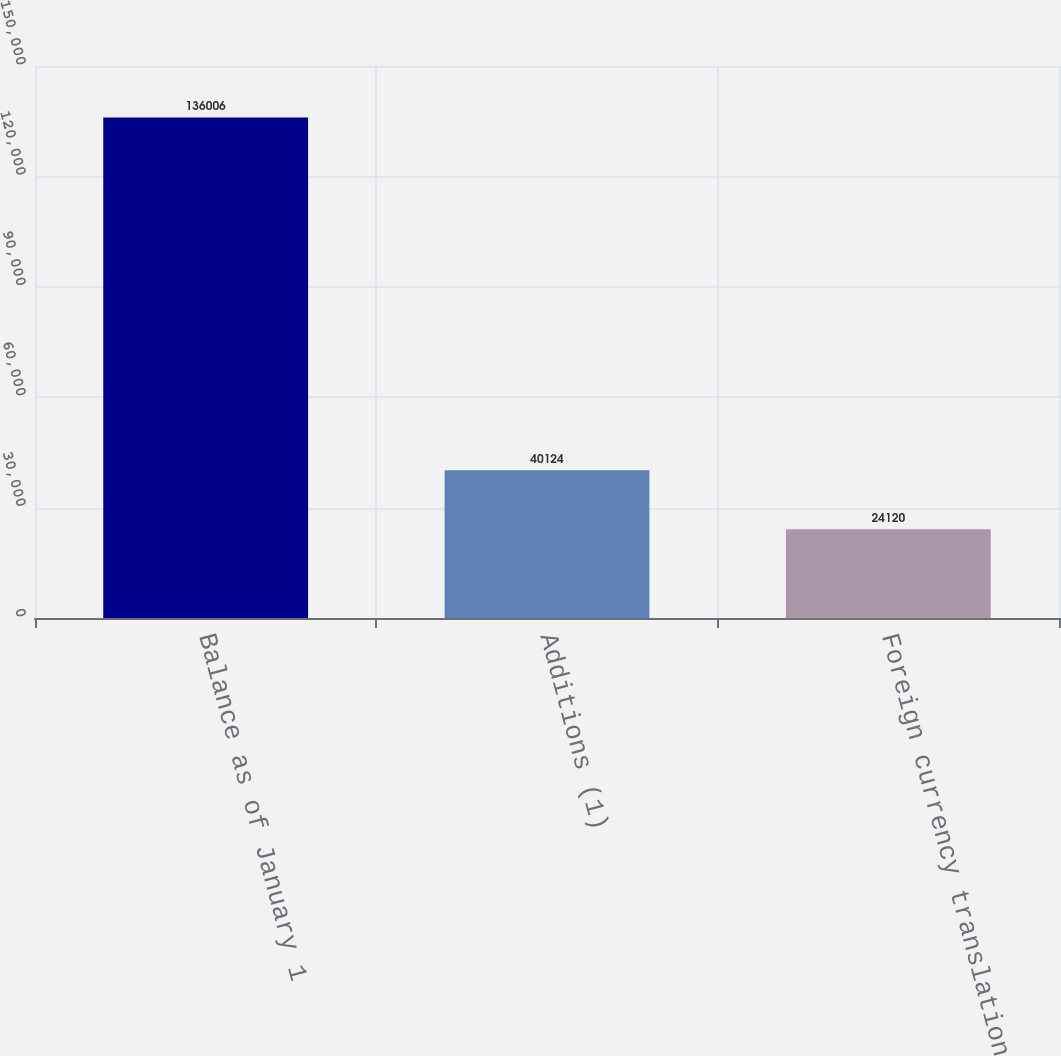<chart> <loc_0><loc_0><loc_500><loc_500><bar_chart><fcel>Balance as of January 1<fcel>Additions (1)<fcel>Foreign currency translation<nl><fcel>136006<fcel>40124<fcel>24120<nl></chart> 